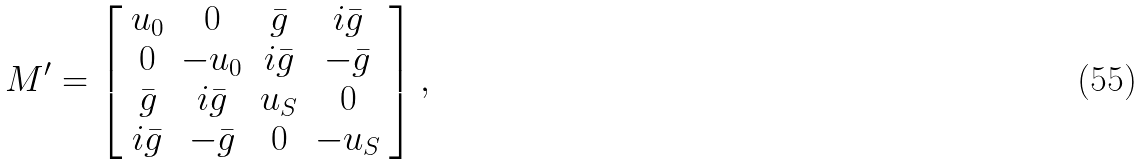<formula> <loc_0><loc_0><loc_500><loc_500>M ^ { \prime } = \left [ \begin{array} { c c c c } u _ { 0 } & 0 & \bar { g } & i \bar { g } \\ 0 & - u _ { 0 } & i \bar { g } & - \bar { g } \\ \bar { g } & i \bar { g } & u _ { S } & 0 \\ i \bar { g } & - \bar { g } & 0 & - u _ { S } \end{array} \right ] ,</formula> 